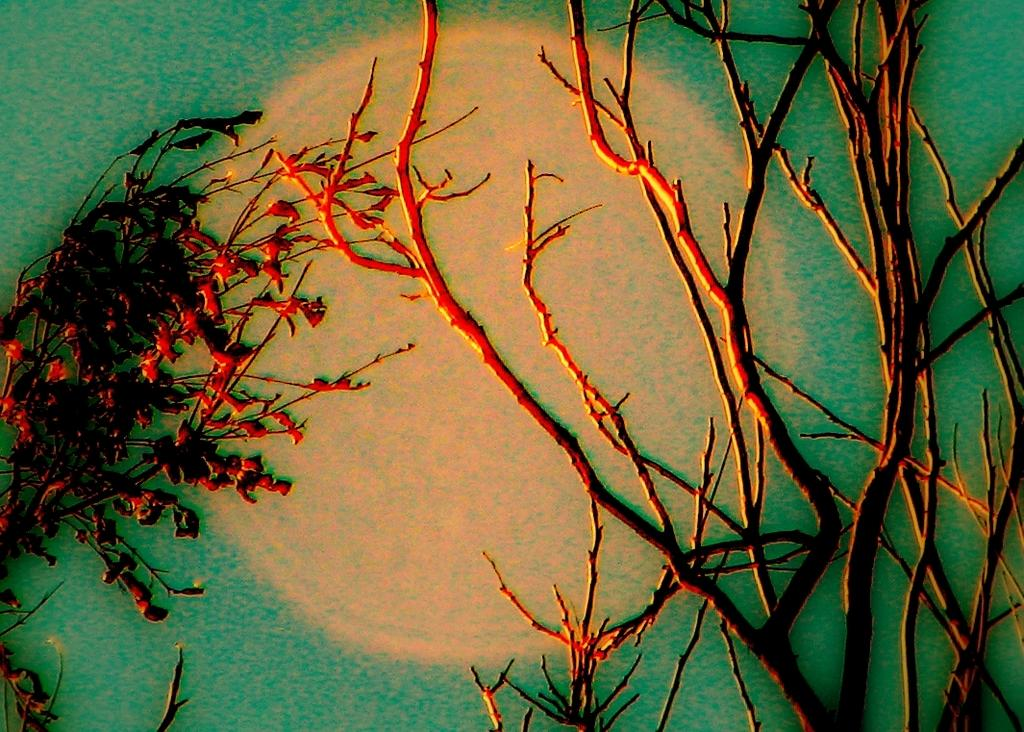What type of artwork is depicted in the image? The image is a painting. What natural elements can be seen in the painting? There are trees and the sky visible in the painting. What celestial body is present in the painting? The moon is present in the painting. What type of soda is being advertised in the painting? There is no soda being advertised in the painting; it is a landscape featuring trees, the sky, and the moon. Can you describe the man standing next to the tree in the painting? There is no man present in the painting; it only features trees, the sky, and the moon. 